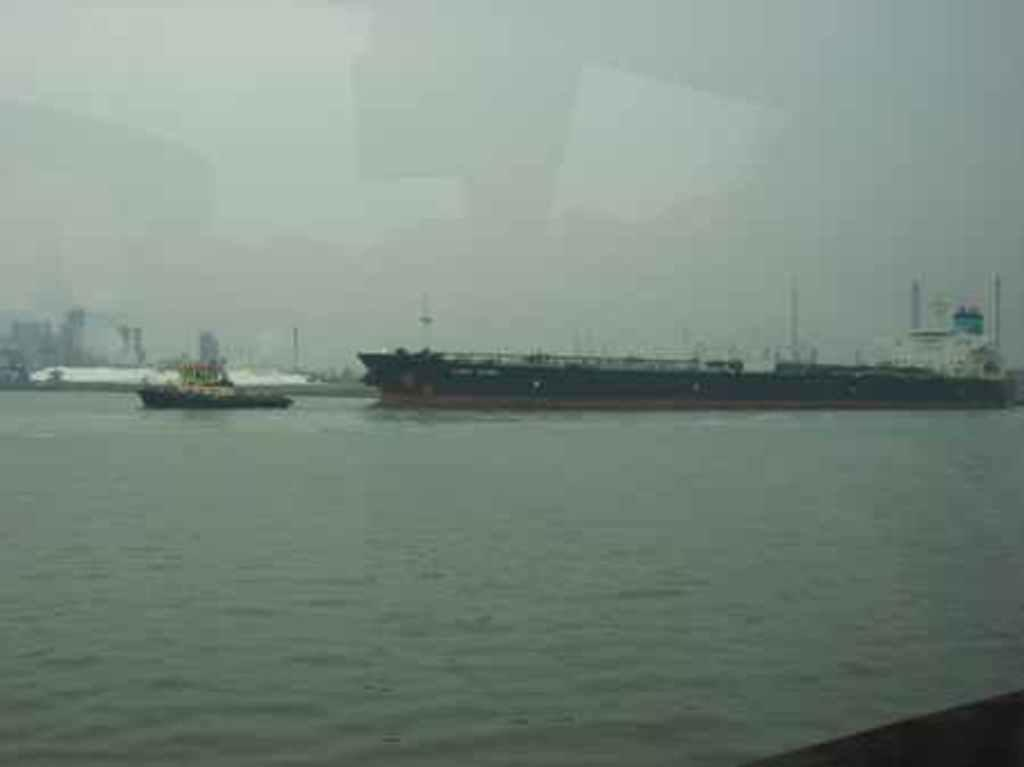What is the main subject of the image? The main subject of the image is ships. Where are the ships located? The ships are in a large water body. What can be seen in the background of the image? There are buildings and poles visible in the background of the image. What is visible in the sky in the image? The sky is visible in the background of the image. What type of hair can be seen on the ships in the image? There is no hair present on the ships in the image. What kind of cheese is being used to anchor the ships in the image? There is no cheese present in the image, and ships are not anchored using cheese. 